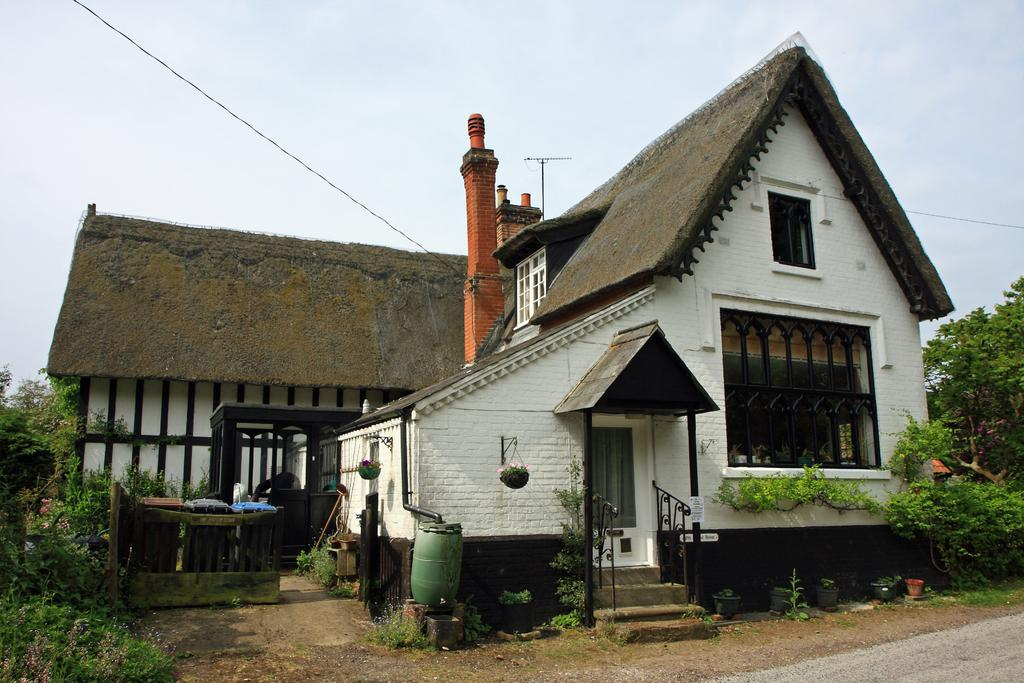What type of structure is present in the image? There is a shed in the image. What other natural elements can be seen in the image? There are trees in the image. What is at the bottom of the image? There is a road at the bottom of the image. What can be seen in the background of the image? The sky is visible in the background of the image. What type of chair is hanging from the tree in the image? There is no chair hanging from a tree in the image; it only features a shed, trees, a road, and the sky. 